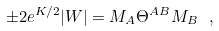Convert formula to latex. <formula><loc_0><loc_0><loc_500><loc_500>\pm 2 e ^ { K / 2 } | W | = M _ { A } \Theta ^ { A B } M _ { B } \ ,</formula> 